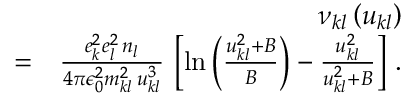<formula> <loc_0><loc_0><loc_500><loc_500>\begin{array} { r l r } & { \nu _ { k l } \left ( u _ { k l } \right ) } \\ & { = } & { \frac { e _ { k } ^ { 2 } e _ { l } ^ { 2 } \, n _ { l } } { 4 \pi \epsilon _ { 0 } ^ { 2 } m _ { k l } ^ { 2 } \, u _ { k l } ^ { 3 } } \, \left [ \ln \left ( \frac { u _ { k l } ^ { 2 } + B } { B } \right ) - \frac { u _ { k l } ^ { 2 } } { u _ { k l } ^ { 2 } + B } \right ] \, . } \end{array}</formula> 